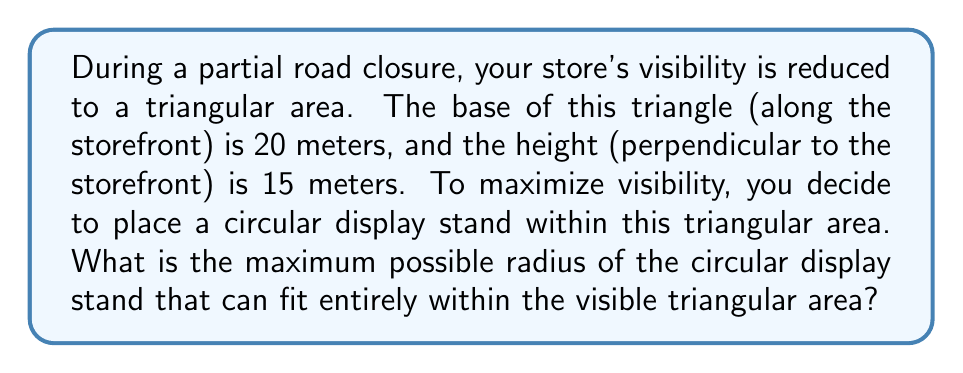Give your solution to this math problem. Let's approach this step-by-step:

1) The visible area forms a right triangle. We know the base (b) and height (h):
   $b = 20$ meters
   $h = 15$ meters

2) To maximize the size of the circular display, its center should be at the incenter of the triangle. The incenter is the point where the angle bisectors of the triangle intersect.

3) In a right triangle, the distance (r) from the incenter to each side of the triangle is given by the formula:

   $$r = \frac{a + b - c}{2}$$

   where a, b, and c are the sides of the triangle.

4) We need to find the hypotenuse (c) using the Pythagorean theorem:

   $$c = \sqrt{b^2 + h^2} = \sqrt{20^2 + 15^2} = \sqrt{625} = 25$$ meters

5) Now we can calculate r:

   $$r = \frac{20 + 15 - 25}{2} = \frac{10}{2} = 5$$ meters

6) Therefore, the maximum radius of the circular display stand that can fit within the visible triangular area is 5 meters.

[asy]
unitsize(10mm);
draw((0,0)--(20,0)--(20,15)--cycle);
dot((20-5,5));
draw(Circle((20-5,5),5));
label("20m",(10,0),S);
label("15m",(20,7.5),E);
label("5m",(20-5,5),NW);
[/asy]
Answer: 5 meters 